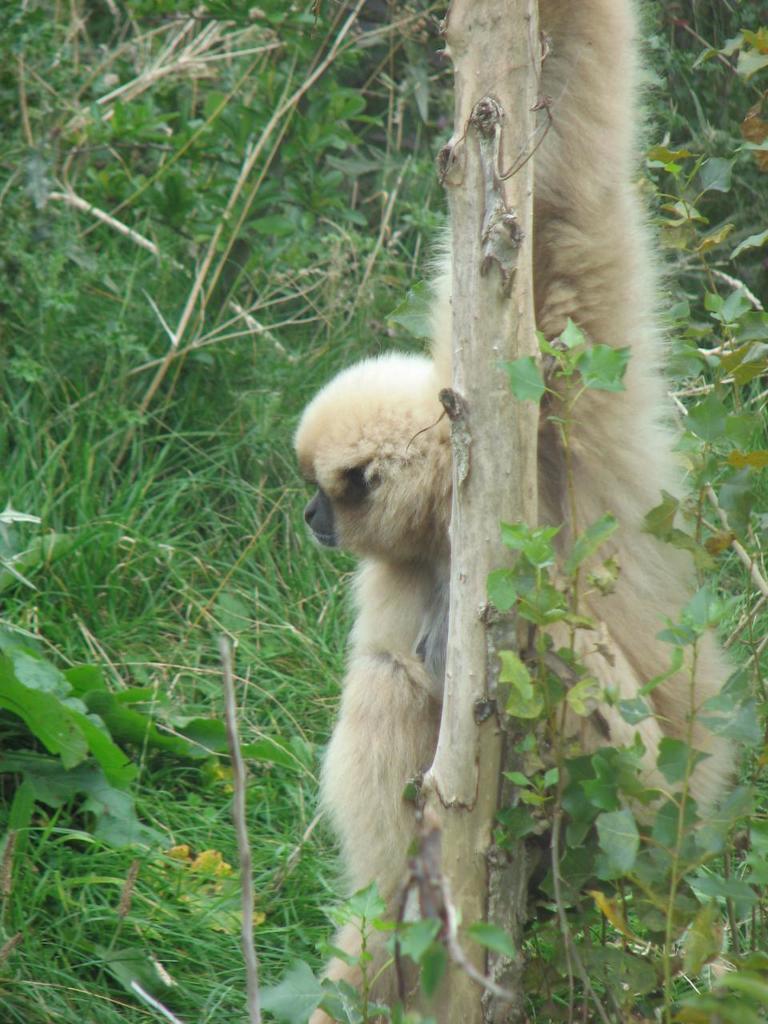How would you summarize this image in a sentence or two? In this picture I can see there is a monkey here and it is holding a tree and there is grass and there are plants. 